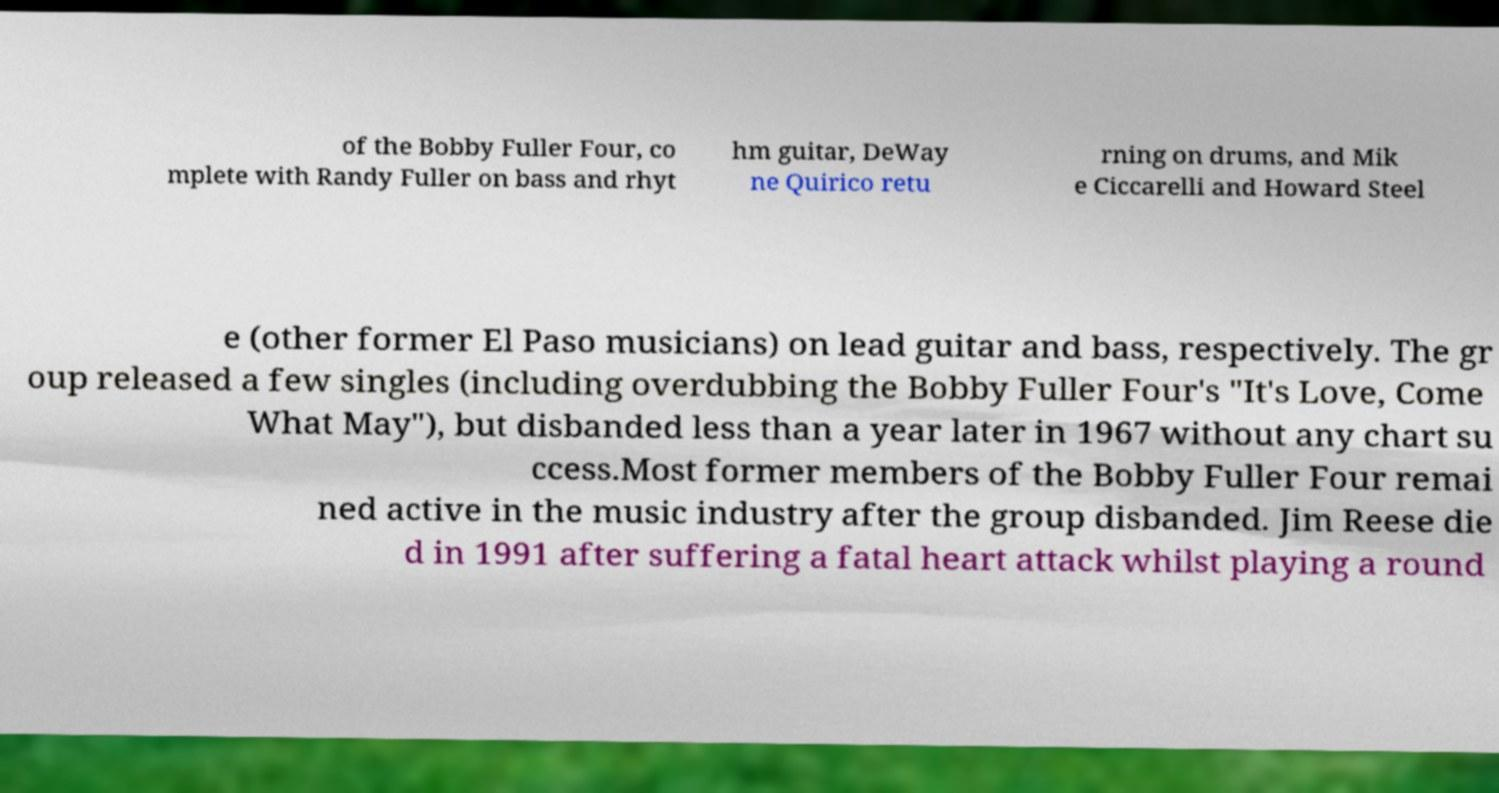I need the written content from this picture converted into text. Can you do that? of the Bobby Fuller Four, co mplete with Randy Fuller on bass and rhyt hm guitar, DeWay ne Quirico retu rning on drums, and Mik e Ciccarelli and Howard Steel e (other former El Paso musicians) on lead guitar and bass, respectively. The gr oup released a few singles (including overdubbing the Bobby Fuller Four's "It's Love, Come What May"), but disbanded less than a year later in 1967 without any chart su ccess.Most former members of the Bobby Fuller Four remai ned active in the music industry after the group disbanded. Jim Reese die d in 1991 after suffering a fatal heart attack whilst playing a round 